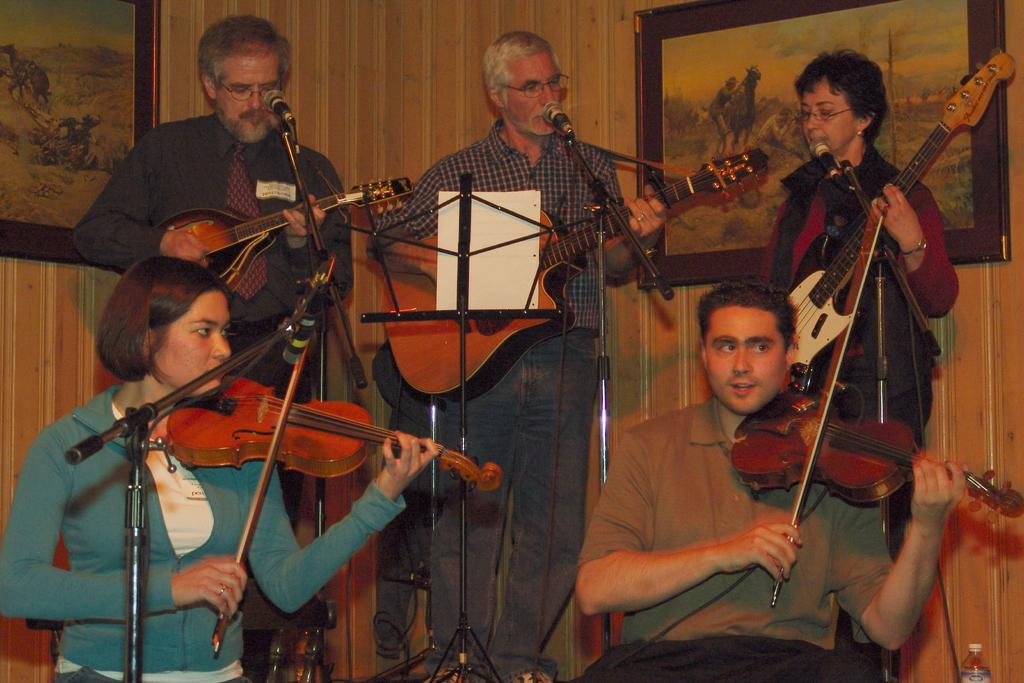How many people are in the image? There are five persons in the image. What are the persons doing in the image? The persons are playing musical instruments and singing on microphones. What specific musical instruments can be seen in the image? The musical instruments include a guitar and a violin. What can be seen in the background of the image? There is a wall with frames in the background of the image. How does the wheel contribute to the musical performance in the image? There is no wheel present in the image, so it does not contribute to the musical performance. What type of muscle is being exercised by the persons while playing the instruments? The image does not provide information about the muscles being exercised by the persons while playing the instruments. 